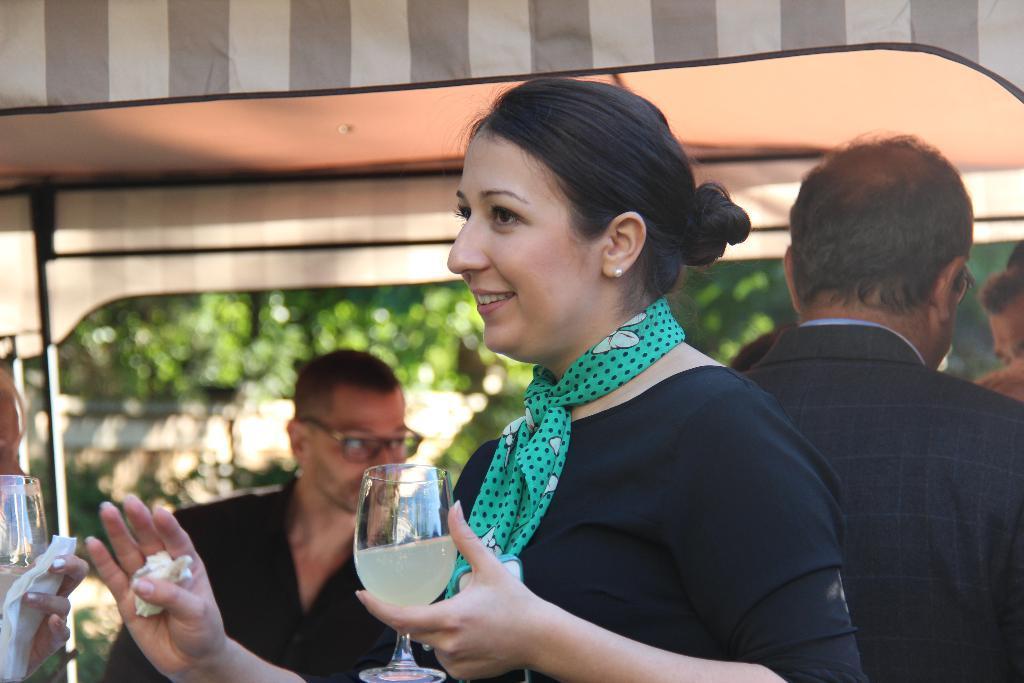How would you summarize this image in a sentence or two? here in this picture we can see a woman holding a glass with her hands and talking to someone present in front of her, here we can see some people behind her ,here we can see trees which are away from the woman. 